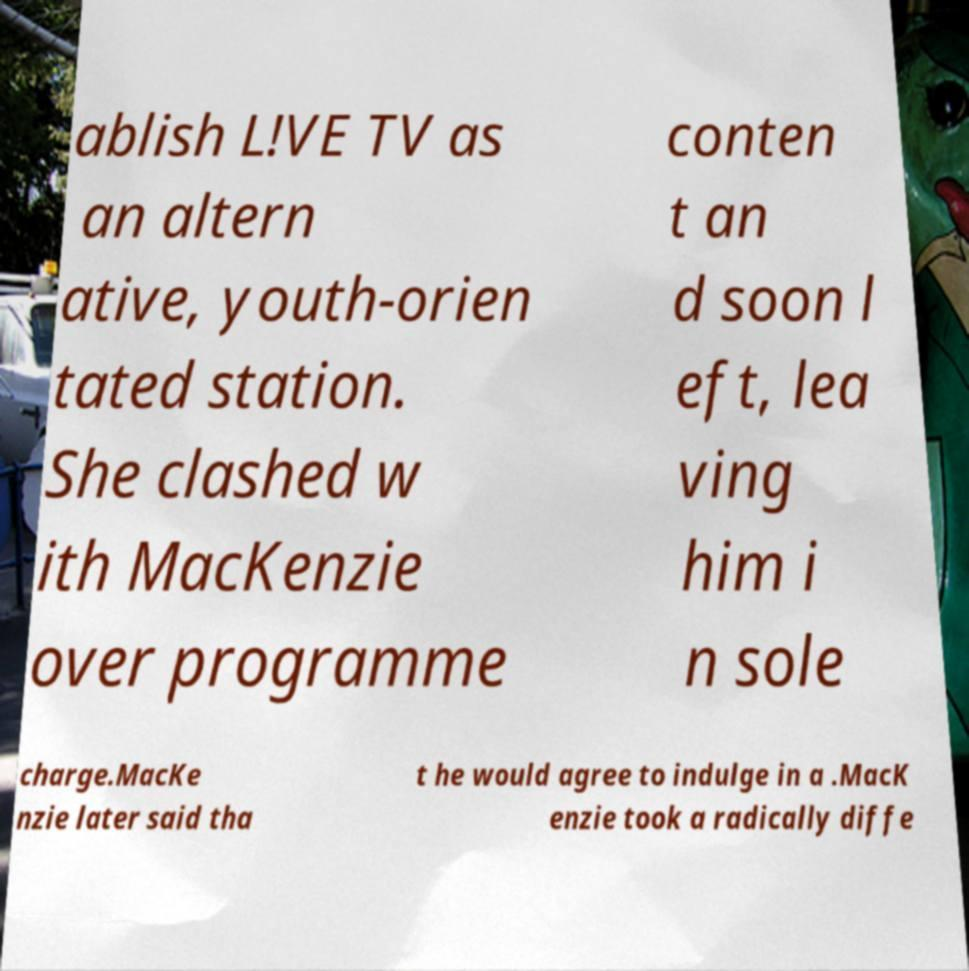There's text embedded in this image that I need extracted. Can you transcribe it verbatim? ablish L!VE TV as an altern ative, youth-orien tated station. She clashed w ith MacKenzie over programme conten t an d soon l eft, lea ving him i n sole charge.MacKe nzie later said tha t he would agree to indulge in a .MacK enzie took a radically diffe 